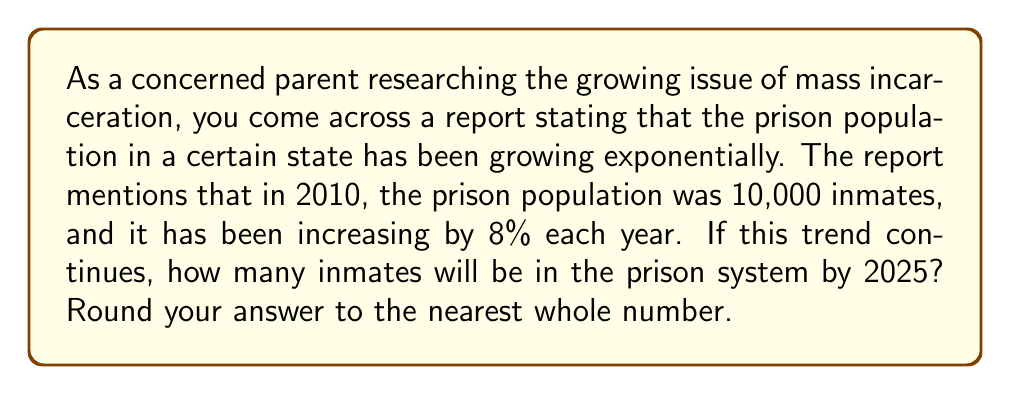Teach me how to tackle this problem. To solve this problem, we need to use the exponential growth formula:

$$A = P(1 + r)^t$$

Where:
$A$ = Final amount
$P$ = Initial principal (starting amount)
$r$ = Growth rate (as a decimal)
$t$ = Time period

Given:
$P = 10,000$ (initial prison population in 2010)
$r = 0.08$ (8% growth rate expressed as a decimal)
$t = 15$ (number of years from 2010 to 2025)

Let's plug these values into the formula:

$$A = 10,000(1 + 0.08)^{15}$$

Now, let's solve step-by-step:

1) First, calculate $(1 + 0.08)$:
   $1 + 0.08 = 1.08$

2) Now, we have:
   $$A = 10,000(1.08)^{15}$$

3) Calculate $(1.08)^{15}$:
   $(1.08)^{15} \approx 3.1722$ (rounded to 4 decimal places)

4) Finally, multiply:
   $$A = 10,000 \times 3.1722 = 31,722$$

5) Rounding to the nearest whole number:
   $A = 31,722$
Answer: 31,722 inmates 